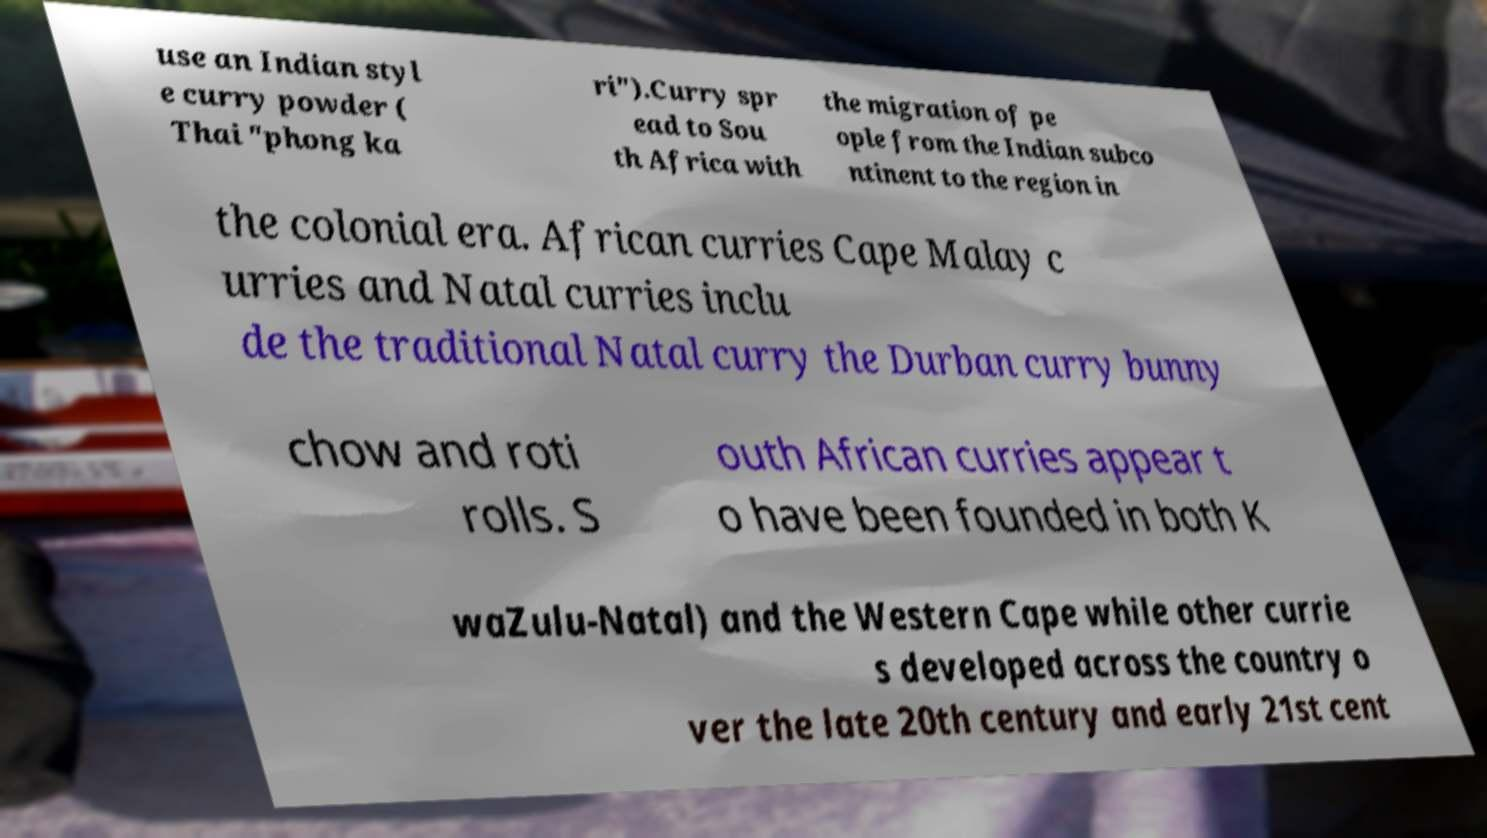Could you extract and type out the text from this image? use an Indian styl e curry powder ( Thai "phong ka ri").Curry spr ead to Sou th Africa with the migration of pe ople from the Indian subco ntinent to the region in the colonial era. African curries Cape Malay c urries and Natal curries inclu de the traditional Natal curry the Durban curry bunny chow and roti rolls. S outh African curries appear t o have been founded in both K waZulu-Natal) and the Western Cape while other currie s developed across the country o ver the late 20th century and early 21st cent 